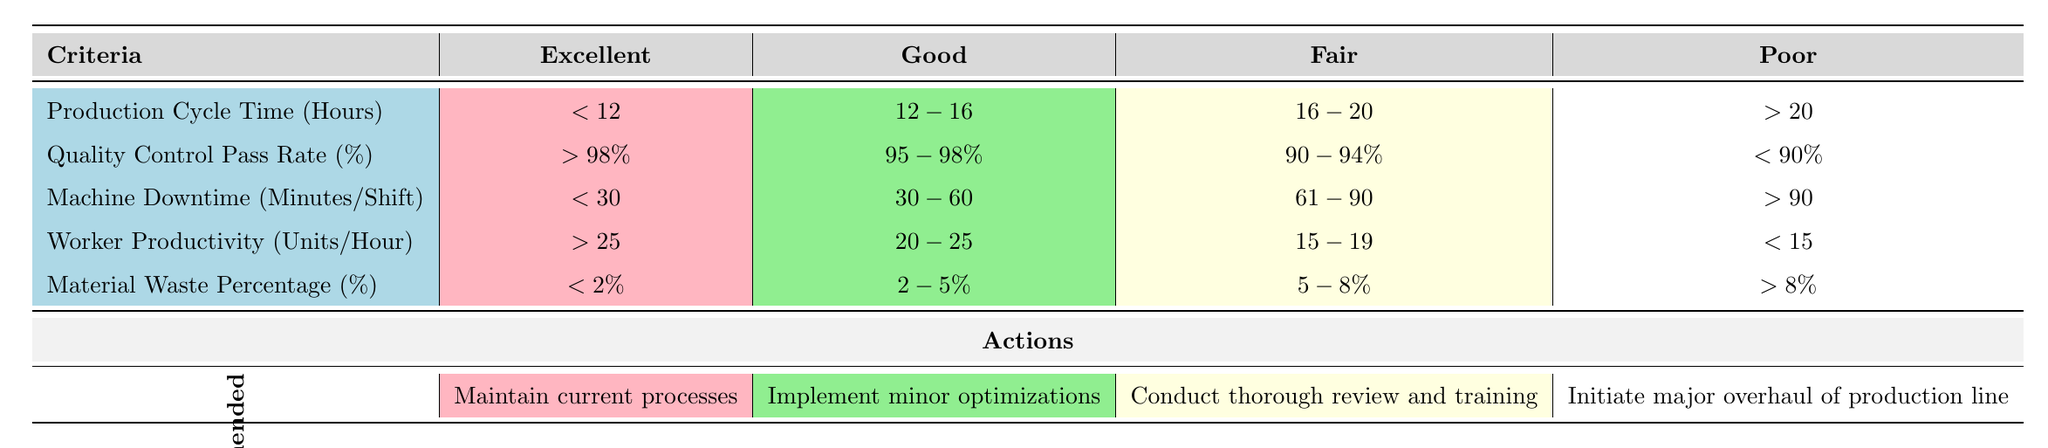What is the threshold for Production Cycle Time to be considered excellent? According to the table, the threshold for the Production Cycle Time to be considered excellent is less than 12 hours.
Answer: Less than 12 hours What is the recommended action if the Quality Control Pass Rate is between 90% and 94%? If the Quality Control Pass Rate falls in the range of 90% to 94%, according to the table's thresholds, the recommended action is to conduct a thorough review and training.
Answer: Conduct a thorough review and training True or False: A machine downtime of 25 minutes per shift falls under the "Good" category. Since the "Good" category for Machine Downtime is between 30 minutes and 60 minutes, a downtime of 25 minutes does not fit into that range. Therefore, the statement is false.
Answer: False What is the difference in the upper limit of Machine Downtime between the Excellent and Fair categories? The upper limit of Machine Downtime for the Excellent category is 30 minutes while for the Fair category it is 90 minutes. Thus, the difference between them is 90 - 30 = 60 minutes.
Answer: 60 minutes If Worker Productivity is at 22 units per hour, what action is recommended? A Worker Productivity of 22 units per hour falls within the "Good" category (20-25 units per hour). Therefore, the recommended action according to the table is to implement minor optimizations.
Answer: Implement minor optimizations What is the average threshold for Material Waste Percentage across all categories? The thresholds for Material Waste Percentage are: Excellent (<2%), Good (2-5%), Fair (5-8%), Poor (>8%). These can be interpreted numerically as roughly 1% for Excellent, 3.5% for Good, 6.5% for Fair, and 9% for Poor. Averaging these values gives (1 + 3.5 + 6.5 + 9) / 4 = 5.75%.
Answer: 5.75% What is the highest threshold for Worker Productivity to still be categorized as "Fair"? The highest threshold for Worker Productivity categorized as Fair is 19 units per hour, as indicated in the table.
Answer: 19 units per hour True or False: A Quality Control Pass Rate of 97% would result in a poor assessment. Since a Quality Control Pass Rate of 97% falls within the "Good" category (95-98%), it is not poor. Therefore, the statement is false.
Answer: False 